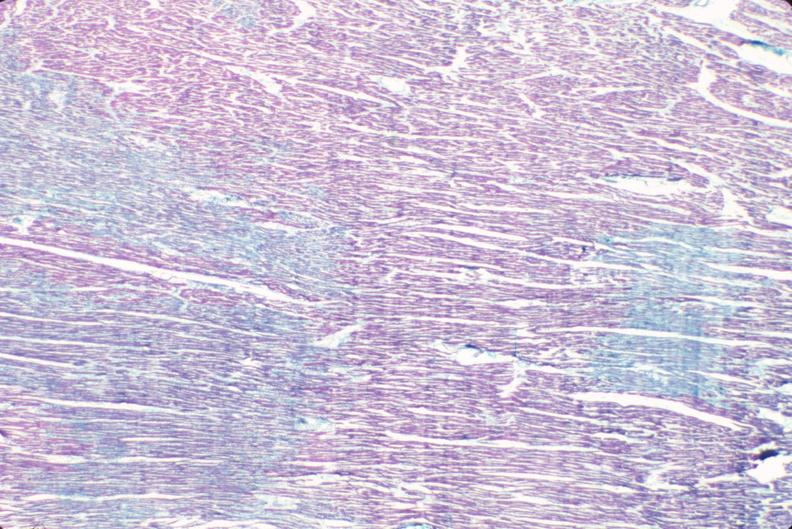what stain?
Answer the question using a single word or phrase. Heart, acute myocardial infarction, aldehyde fuscin 